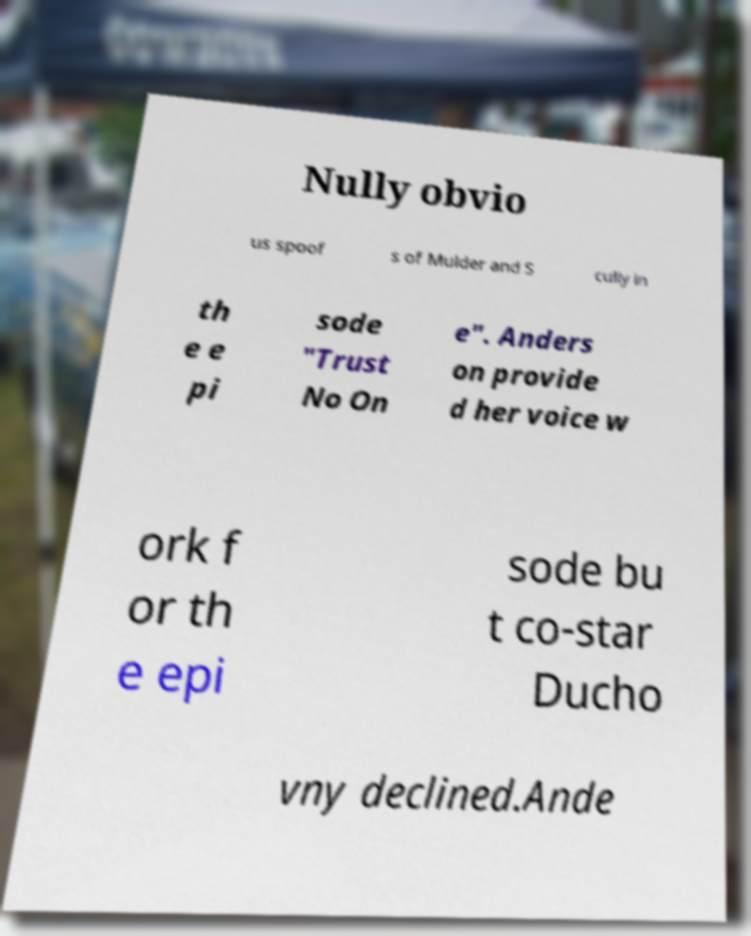For documentation purposes, I need the text within this image transcribed. Could you provide that? Nully obvio us spoof s of Mulder and S cully in th e e pi sode "Trust No On e". Anders on provide d her voice w ork f or th e epi sode bu t co-star Ducho vny declined.Ande 